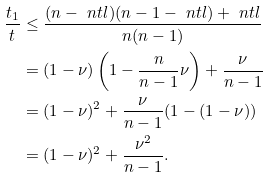Convert formula to latex. <formula><loc_0><loc_0><loc_500><loc_500>\frac { t _ { 1 } } { t } & \leq \frac { ( n - \ n t l ) ( n - 1 - \ n t l ) + \ n t l } { n ( n - 1 ) } \\ & = ( 1 - \nu ) \left ( 1 - \frac { n } { n - 1 } \nu \right ) + \frac { \nu } { n - 1 } \\ & = ( 1 - \nu ) ^ { 2 } + \frac { \nu } { n - 1 } ( 1 - ( 1 - \nu ) ) \\ & = ( 1 - \nu ) ^ { 2 } + \frac { \nu ^ { 2 } } { n - 1 } .</formula> 